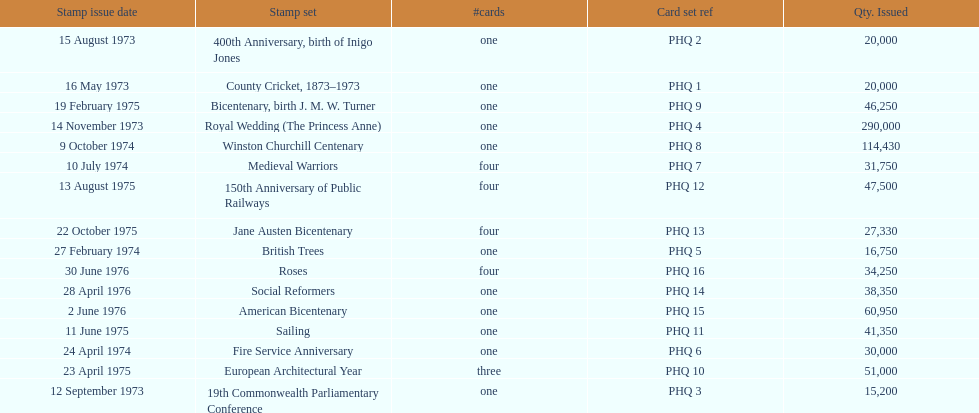How many stamp sets had at least 50,000 issued? 4. 